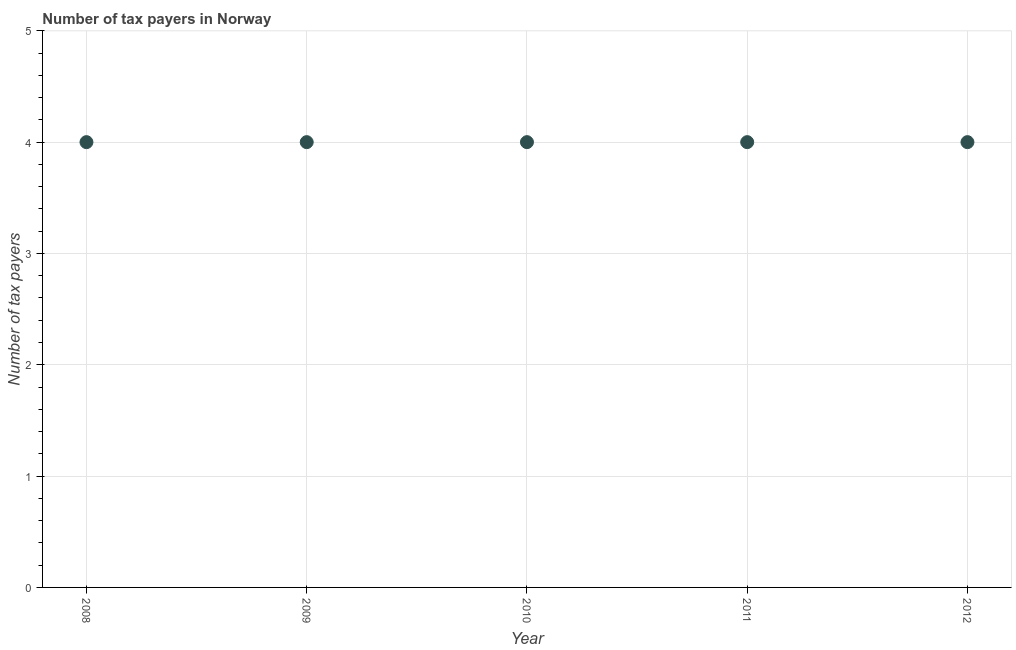What is the number of tax payers in 2012?
Offer a terse response. 4. Across all years, what is the maximum number of tax payers?
Keep it short and to the point. 4. Across all years, what is the minimum number of tax payers?
Provide a succinct answer. 4. In which year was the number of tax payers minimum?
Keep it short and to the point. 2008. What is the sum of the number of tax payers?
Your response must be concise. 20. What is the difference between the number of tax payers in 2010 and 2012?
Make the answer very short. 0. What is the median number of tax payers?
Your answer should be compact. 4. In how many years, is the number of tax payers greater than 3.8 ?
Your response must be concise. 5. Do a majority of the years between 2009 and 2011 (inclusive) have number of tax payers greater than 2.8 ?
Provide a short and direct response. Yes. Is the number of tax payers in 2008 less than that in 2012?
Provide a short and direct response. No. Is the difference between the number of tax payers in 2010 and 2012 greater than the difference between any two years?
Offer a very short reply. Yes. What is the difference between the highest and the second highest number of tax payers?
Ensure brevity in your answer.  0. In how many years, is the number of tax payers greater than the average number of tax payers taken over all years?
Offer a terse response. 0. Does the number of tax payers monotonically increase over the years?
Make the answer very short. No. How many dotlines are there?
Give a very brief answer. 1. Are the values on the major ticks of Y-axis written in scientific E-notation?
Your answer should be compact. No. Does the graph contain grids?
Make the answer very short. Yes. What is the title of the graph?
Your answer should be compact. Number of tax payers in Norway. What is the label or title of the Y-axis?
Provide a succinct answer. Number of tax payers. What is the Number of tax payers in 2008?
Make the answer very short. 4. What is the Number of tax payers in 2011?
Give a very brief answer. 4. What is the difference between the Number of tax payers in 2008 and 2011?
Make the answer very short. 0. What is the difference between the Number of tax payers in 2009 and 2010?
Provide a short and direct response. 0. What is the difference between the Number of tax payers in 2009 and 2011?
Your answer should be compact. 0. What is the difference between the Number of tax payers in 2009 and 2012?
Provide a succinct answer. 0. What is the difference between the Number of tax payers in 2010 and 2011?
Your response must be concise. 0. What is the difference between the Number of tax payers in 2011 and 2012?
Make the answer very short. 0. What is the ratio of the Number of tax payers in 2008 to that in 2012?
Provide a succinct answer. 1. What is the ratio of the Number of tax payers in 2009 to that in 2010?
Keep it short and to the point. 1. What is the ratio of the Number of tax payers in 2009 to that in 2012?
Provide a short and direct response. 1. What is the ratio of the Number of tax payers in 2010 to that in 2011?
Ensure brevity in your answer.  1. What is the ratio of the Number of tax payers in 2010 to that in 2012?
Make the answer very short. 1. What is the ratio of the Number of tax payers in 2011 to that in 2012?
Your answer should be very brief. 1. 